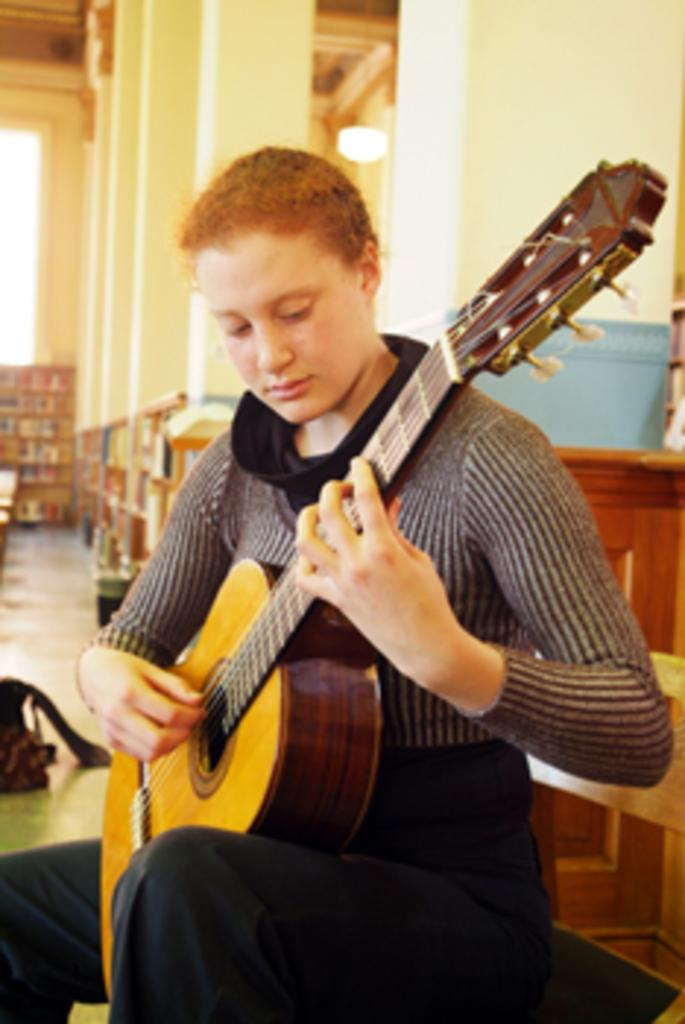What is the main subject of the image? There is a person in the image. What is the person doing in the image? The person is sitting. What object is the person holding in the image? The person is holding a guitar in her hand. What type of bomb can be seen in the image? There is no bomb present in the image. Can you tell me how many toads are visible in the image? There are no toads visible in the image. 